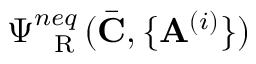<formula> <loc_0><loc_0><loc_500><loc_500>\Psi _ { R } ^ { n e q } ( \bar { C } , \{ A ^ { ( i ) } \} )</formula> 